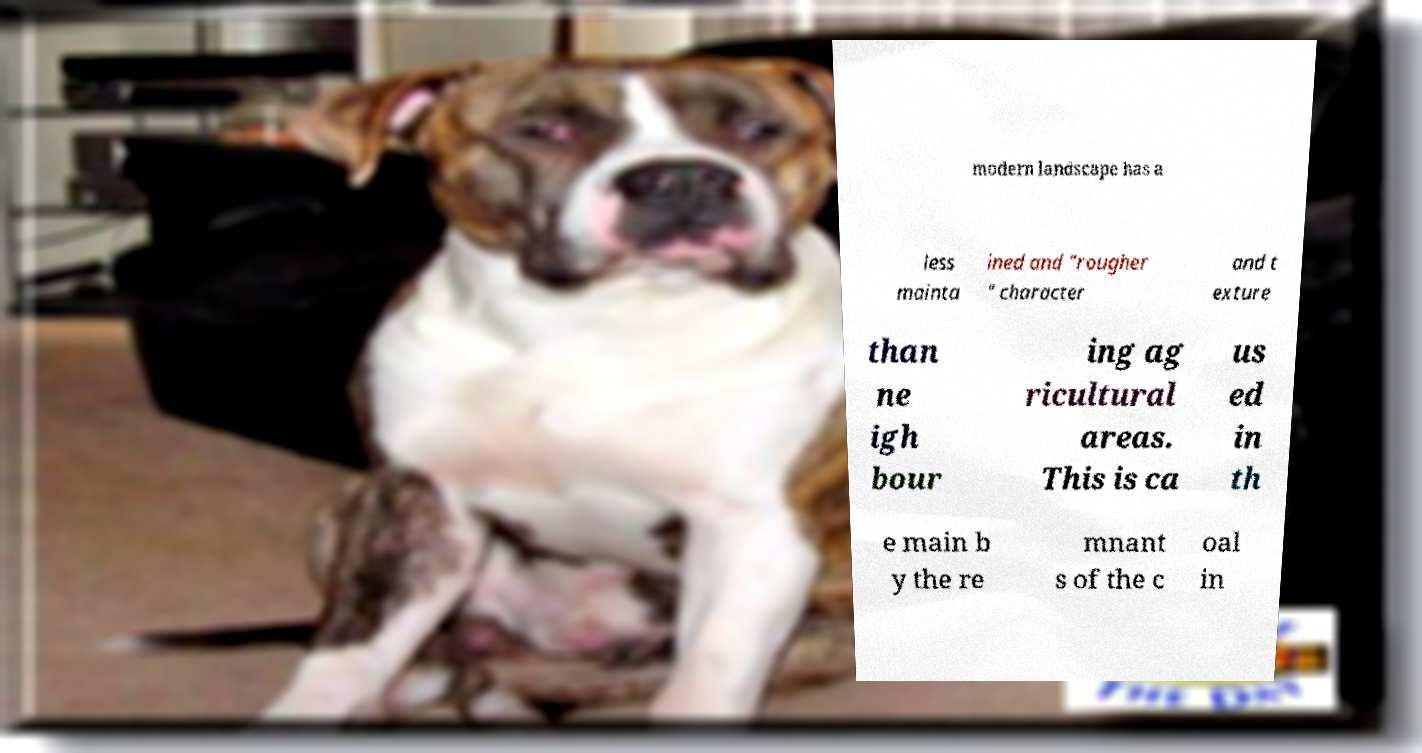Please read and relay the text visible in this image. What does it say? modern landscape has a less mainta ined and "rougher " character and t exture than ne igh bour ing ag ricultural areas. This is ca us ed in th e main b y the re mnant s of the c oal in 